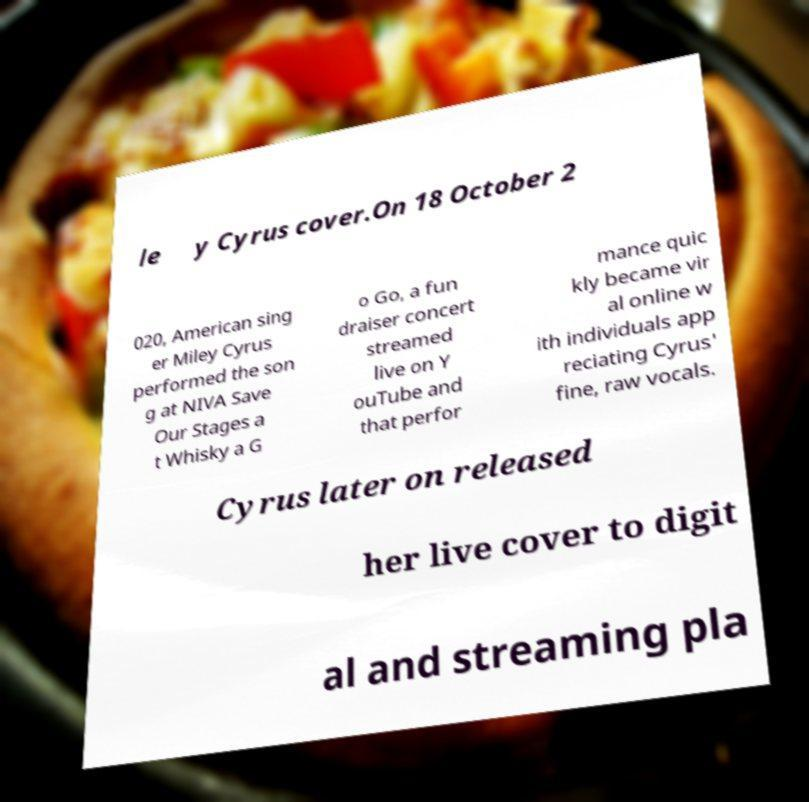Could you extract and type out the text from this image? le y Cyrus cover.On 18 October 2 020, American sing er Miley Cyrus performed the son g at NIVA Save Our Stages a t Whisky a G o Go, a fun draiser concert streamed live on Y ouTube and that perfor mance quic kly became vir al online w ith individuals app reciating Cyrus' fine, raw vocals. Cyrus later on released her live cover to digit al and streaming pla 